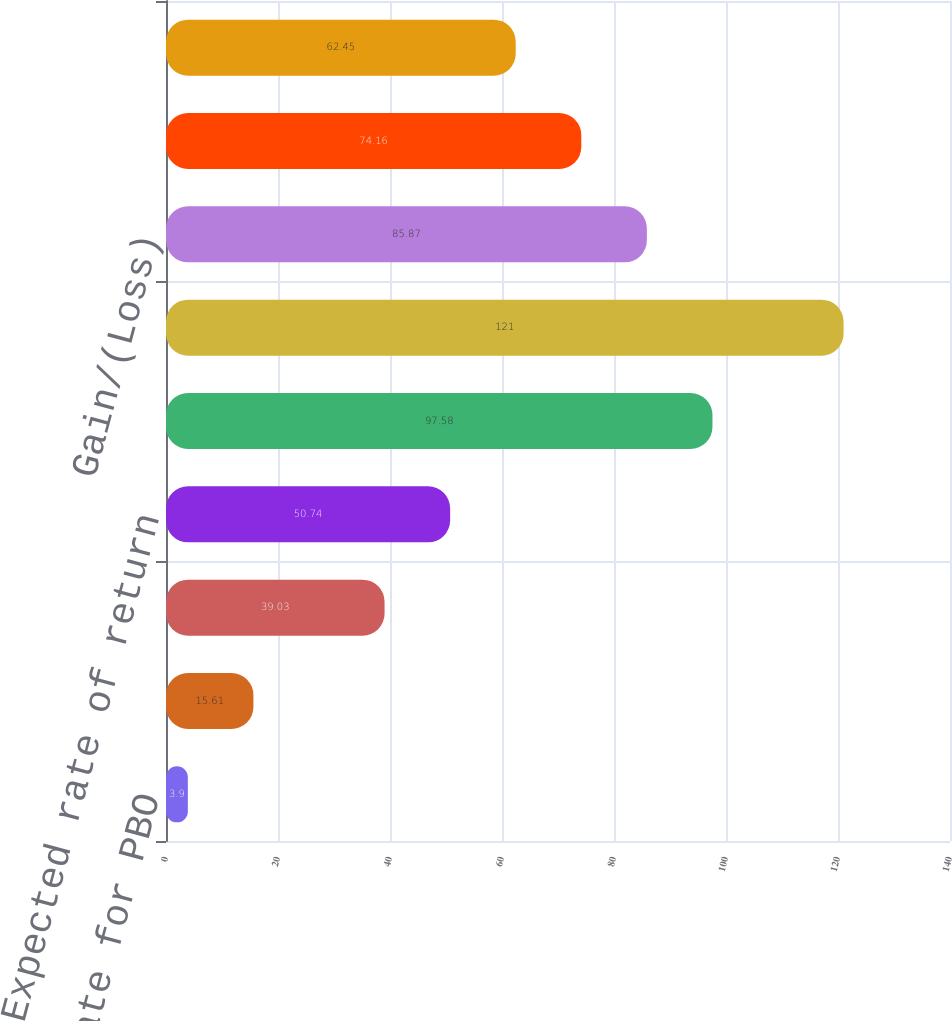<chart> <loc_0><loc_0><loc_500><loc_500><bar_chart><fcel>Discount rate for PBO<fcel>Discount rate for Service Cost<fcel>Discount rate for Interest on<fcel>Expected rate of return<fcel>Expected return<fcel>Actual return<fcel>Gain/(Loss)<fcel>One year actual return<fcel>Five year actual return<nl><fcel>3.9<fcel>15.61<fcel>39.03<fcel>50.74<fcel>97.58<fcel>121<fcel>85.87<fcel>74.16<fcel>62.45<nl></chart> 